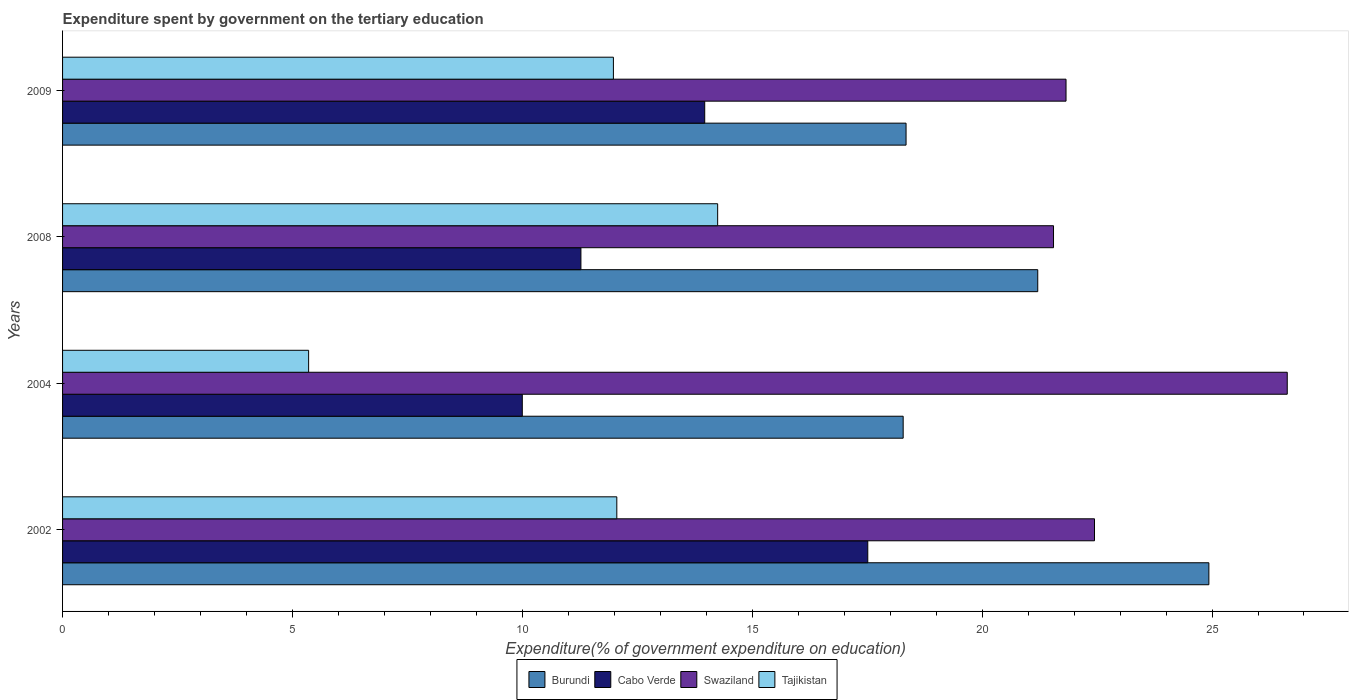How many groups of bars are there?
Give a very brief answer. 4. Are the number of bars per tick equal to the number of legend labels?
Provide a short and direct response. Yes. Are the number of bars on each tick of the Y-axis equal?
Ensure brevity in your answer.  Yes. How many bars are there on the 1st tick from the bottom?
Ensure brevity in your answer.  4. What is the expenditure spent by government on the tertiary education in Tajikistan in 2008?
Your response must be concise. 14.25. Across all years, what is the maximum expenditure spent by government on the tertiary education in Swaziland?
Keep it short and to the point. 26.64. Across all years, what is the minimum expenditure spent by government on the tertiary education in Burundi?
Make the answer very short. 18.28. In which year was the expenditure spent by government on the tertiary education in Tajikistan maximum?
Offer a terse response. 2008. In which year was the expenditure spent by government on the tertiary education in Cabo Verde minimum?
Your answer should be very brief. 2004. What is the total expenditure spent by government on the tertiary education in Cabo Verde in the graph?
Make the answer very short. 52.75. What is the difference between the expenditure spent by government on the tertiary education in Cabo Verde in 2004 and that in 2009?
Provide a short and direct response. -3.97. What is the difference between the expenditure spent by government on the tertiary education in Tajikistan in 2004 and the expenditure spent by government on the tertiary education in Swaziland in 2009?
Offer a very short reply. -16.47. What is the average expenditure spent by government on the tertiary education in Cabo Verde per year?
Your answer should be compact. 13.19. In the year 2009, what is the difference between the expenditure spent by government on the tertiary education in Swaziland and expenditure spent by government on the tertiary education in Cabo Verde?
Provide a short and direct response. 7.86. What is the ratio of the expenditure spent by government on the tertiary education in Tajikistan in 2008 to that in 2009?
Offer a terse response. 1.19. Is the expenditure spent by government on the tertiary education in Cabo Verde in 2008 less than that in 2009?
Provide a succinct answer. Yes. What is the difference between the highest and the second highest expenditure spent by government on the tertiary education in Cabo Verde?
Your answer should be very brief. 3.55. What is the difference between the highest and the lowest expenditure spent by government on the tertiary education in Tajikistan?
Make the answer very short. 8.9. In how many years, is the expenditure spent by government on the tertiary education in Cabo Verde greater than the average expenditure spent by government on the tertiary education in Cabo Verde taken over all years?
Give a very brief answer. 2. Is it the case that in every year, the sum of the expenditure spent by government on the tertiary education in Tajikistan and expenditure spent by government on the tertiary education in Burundi is greater than the sum of expenditure spent by government on the tertiary education in Swaziland and expenditure spent by government on the tertiary education in Cabo Verde?
Offer a terse response. No. What does the 2nd bar from the top in 2002 represents?
Offer a terse response. Swaziland. What does the 3rd bar from the bottom in 2004 represents?
Keep it short and to the point. Swaziland. Are all the bars in the graph horizontal?
Ensure brevity in your answer.  Yes. What is the difference between two consecutive major ticks on the X-axis?
Provide a succinct answer. 5. How many legend labels are there?
Your answer should be very brief. 4. How are the legend labels stacked?
Give a very brief answer. Horizontal. What is the title of the graph?
Make the answer very short. Expenditure spent by government on the tertiary education. Does "Egypt, Arab Rep." appear as one of the legend labels in the graph?
Give a very brief answer. No. What is the label or title of the X-axis?
Keep it short and to the point. Expenditure(% of government expenditure on education). What is the Expenditure(% of government expenditure on education) of Burundi in 2002?
Provide a short and direct response. 24.93. What is the Expenditure(% of government expenditure on education) of Cabo Verde in 2002?
Give a very brief answer. 17.51. What is the Expenditure(% of government expenditure on education) in Swaziland in 2002?
Your response must be concise. 22.44. What is the Expenditure(% of government expenditure on education) in Tajikistan in 2002?
Your response must be concise. 12.05. What is the Expenditure(% of government expenditure on education) in Burundi in 2004?
Your answer should be very brief. 18.28. What is the Expenditure(% of government expenditure on education) in Cabo Verde in 2004?
Keep it short and to the point. 10. What is the Expenditure(% of government expenditure on education) of Swaziland in 2004?
Keep it short and to the point. 26.64. What is the Expenditure(% of government expenditure on education) in Tajikistan in 2004?
Provide a succinct answer. 5.35. What is the Expenditure(% of government expenditure on education) of Burundi in 2008?
Your response must be concise. 21.21. What is the Expenditure(% of government expenditure on education) of Cabo Verde in 2008?
Your answer should be compact. 11.27. What is the Expenditure(% of government expenditure on education) in Swaziland in 2008?
Offer a terse response. 21.55. What is the Expenditure(% of government expenditure on education) in Tajikistan in 2008?
Offer a very short reply. 14.25. What is the Expenditure(% of government expenditure on education) of Burundi in 2009?
Provide a succinct answer. 18.35. What is the Expenditure(% of government expenditure on education) of Cabo Verde in 2009?
Give a very brief answer. 13.97. What is the Expenditure(% of government expenditure on education) in Swaziland in 2009?
Provide a short and direct response. 21.82. What is the Expenditure(% of government expenditure on education) in Tajikistan in 2009?
Offer a terse response. 11.98. Across all years, what is the maximum Expenditure(% of government expenditure on education) in Burundi?
Make the answer very short. 24.93. Across all years, what is the maximum Expenditure(% of government expenditure on education) of Cabo Verde?
Your answer should be very brief. 17.51. Across all years, what is the maximum Expenditure(% of government expenditure on education) of Swaziland?
Ensure brevity in your answer.  26.64. Across all years, what is the maximum Expenditure(% of government expenditure on education) of Tajikistan?
Provide a succinct answer. 14.25. Across all years, what is the minimum Expenditure(% of government expenditure on education) of Burundi?
Provide a short and direct response. 18.28. Across all years, what is the minimum Expenditure(% of government expenditure on education) of Cabo Verde?
Your response must be concise. 10. Across all years, what is the minimum Expenditure(% of government expenditure on education) in Swaziland?
Give a very brief answer. 21.55. Across all years, what is the minimum Expenditure(% of government expenditure on education) of Tajikistan?
Make the answer very short. 5.35. What is the total Expenditure(% of government expenditure on education) of Burundi in the graph?
Your answer should be compact. 82.77. What is the total Expenditure(% of government expenditure on education) in Cabo Verde in the graph?
Provide a short and direct response. 52.75. What is the total Expenditure(% of government expenditure on education) in Swaziland in the graph?
Keep it short and to the point. 92.46. What is the total Expenditure(% of government expenditure on education) of Tajikistan in the graph?
Offer a terse response. 43.63. What is the difference between the Expenditure(% of government expenditure on education) of Burundi in 2002 and that in 2004?
Offer a very short reply. 6.65. What is the difference between the Expenditure(% of government expenditure on education) in Cabo Verde in 2002 and that in 2004?
Give a very brief answer. 7.51. What is the difference between the Expenditure(% of government expenditure on education) of Swaziland in 2002 and that in 2004?
Ensure brevity in your answer.  -4.19. What is the difference between the Expenditure(% of government expenditure on education) of Tajikistan in 2002 and that in 2004?
Provide a succinct answer. 6.7. What is the difference between the Expenditure(% of government expenditure on education) of Burundi in 2002 and that in 2008?
Provide a succinct answer. 3.72. What is the difference between the Expenditure(% of government expenditure on education) of Cabo Verde in 2002 and that in 2008?
Your answer should be compact. 6.24. What is the difference between the Expenditure(% of government expenditure on education) of Swaziland in 2002 and that in 2008?
Ensure brevity in your answer.  0.89. What is the difference between the Expenditure(% of government expenditure on education) of Tajikistan in 2002 and that in 2008?
Your answer should be very brief. -2.19. What is the difference between the Expenditure(% of government expenditure on education) of Burundi in 2002 and that in 2009?
Your answer should be very brief. 6.59. What is the difference between the Expenditure(% of government expenditure on education) of Cabo Verde in 2002 and that in 2009?
Your answer should be very brief. 3.55. What is the difference between the Expenditure(% of government expenditure on education) in Swaziland in 2002 and that in 2009?
Your answer should be compact. 0.62. What is the difference between the Expenditure(% of government expenditure on education) in Tajikistan in 2002 and that in 2009?
Offer a very short reply. 0.07. What is the difference between the Expenditure(% of government expenditure on education) of Burundi in 2004 and that in 2008?
Provide a short and direct response. -2.93. What is the difference between the Expenditure(% of government expenditure on education) in Cabo Verde in 2004 and that in 2008?
Provide a short and direct response. -1.28. What is the difference between the Expenditure(% of government expenditure on education) of Swaziland in 2004 and that in 2008?
Give a very brief answer. 5.08. What is the difference between the Expenditure(% of government expenditure on education) in Tajikistan in 2004 and that in 2008?
Offer a very short reply. -8.9. What is the difference between the Expenditure(% of government expenditure on education) of Burundi in 2004 and that in 2009?
Offer a terse response. -0.06. What is the difference between the Expenditure(% of government expenditure on education) in Cabo Verde in 2004 and that in 2009?
Your answer should be compact. -3.97. What is the difference between the Expenditure(% of government expenditure on education) in Swaziland in 2004 and that in 2009?
Provide a succinct answer. 4.81. What is the difference between the Expenditure(% of government expenditure on education) in Tajikistan in 2004 and that in 2009?
Offer a very short reply. -6.63. What is the difference between the Expenditure(% of government expenditure on education) in Burundi in 2008 and that in 2009?
Make the answer very short. 2.86. What is the difference between the Expenditure(% of government expenditure on education) in Cabo Verde in 2008 and that in 2009?
Offer a terse response. -2.69. What is the difference between the Expenditure(% of government expenditure on education) of Swaziland in 2008 and that in 2009?
Provide a succinct answer. -0.27. What is the difference between the Expenditure(% of government expenditure on education) of Tajikistan in 2008 and that in 2009?
Your response must be concise. 2.27. What is the difference between the Expenditure(% of government expenditure on education) in Burundi in 2002 and the Expenditure(% of government expenditure on education) in Cabo Verde in 2004?
Ensure brevity in your answer.  14.93. What is the difference between the Expenditure(% of government expenditure on education) in Burundi in 2002 and the Expenditure(% of government expenditure on education) in Swaziland in 2004?
Your response must be concise. -1.7. What is the difference between the Expenditure(% of government expenditure on education) in Burundi in 2002 and the Expenditure(% of government expenditure on education) in Tajikistan in 2004?
Offer a terse response. 19.58. What is the difference between the Expenditure(% of government expenditure on education) of Cabo Verde in 2002 and the Expenditure(% of government expenditure on education) of Swaziland in 2004?
Your answer should be very brief. -9.12. What is the difference between the Expenditure(% of government expenditure on education) of Cabo Verde in 2002 and the Expenditure(% of government expenditure on education) of Tajikistan in 2004?
Provide a succinct answer. 12.16. What is the difference between the Expenditure(% of government expenditure on education) in Swaziland in 2002 and the Expenditure(% of government expenditure on education) in Tajikistan in 2004?
Ensure brevity in your answer.  17.09. What is the difference between the Expenditure(% of government expenditure on education) of Burundi in 2002 and the Expenditure(% of government expenditure on education) of Cabo Verde in 2008?
Provide a succinct answer. 13.66. What is the difference between the Expenditure(% of government expenditure on education) of Burundi in 2002 and the Expenditure(% of government expenditure on education) of Swaziland in 2008?
Provide a succinct answer. 3.38. What is the difference between the Expenditure(% of government expenditure on education) in Burundi in 2002 and the Expenditure(% of government expenditure on education) in Tajikistan in 2008?
Your answer should be compact. 10.68. What is the difference between the Expenditure(% of government expenditure on education) in Cabo Verde in 2002 and the Expenditure(% of government expenditure on education) in Swaziland in 2008?
Keep it short and to the point. -4.04. What is the difference between the Expenditure(% of government expenditure on education) in Cabo Verde in 2002 and the Expenditure(% of government expenditure on education) in Tajikistan in 2008?
Your response must be concise. 3.27. What is the difference between the Expenditure(% of government expenditure on education) of Swaziland in 2002 and the Expenditure(% of government expenditure on education) of Tajikistan in 2008?
Ensure brevity in your answer.  8.2. What is the difference between the Expenditure(% of government expenditure on education) in Burundi in 2002 and the Expenditure(% of government expenditure on education) in Cabo Verde in 2009?
Keep it short and to the point. 10.97. What is the difference between the Expenditure(% of government expenditure on education) of Burundi in 2002 and the Expenditure(% of government expenditure on education) of Swaziland in 2009?
Make the answer very short. 3.11. What is the difference between the Expenditure(% of government expenditure on education) in Burundi in 2002 and the Expenditure(% of government expenditure on education) in Tajikistan in 2009?
Offer a very short reply. 12.95. What is the difference between the Expenditure(% of government expenditure on education) in Cabo Verde in 2002 and the Expenditure(% of government expenditure on education) in Swaziland in 2009?
Offer a terse response. -4.31. What is the difference between the Expenditure(% of government expenditure on education) in Cabo Verde in 2002 and the Expenditure(% of government expenditure on education) in Tajikistan in 2009?
Ensure brevity in your answer.  5.53. What is the difference between the Expenditure(% of government expenditure on education) of Swaziland in 2002 and the Expenditure(% of government expenditure on education) of Tajikistan in 2009?
Provide a short and direct response. 10.46. What is the difference between the Expenditure(% of government expenditure on education) of Burundi in 2004 and the Expenditure(% of government expenditure on education) of Cabo Verde in 2008?
Make the answer very short. 7.01. What is the difference between the Expenditure(% of government expenditure on education) in Burundi in 2004 and the Expenditure(% of government expenditure on education) in Swaziland in 2008?
Your response must be concise. -3.27. What is the difference between the Expenditure(% of government expenditure on education) of Burundi in 2004 and the Expenditure(% of government expenditure on education) of Tajikistan in 2008?
Your answer should be very brief. 4.04. What is the difference between the Expenditure(% of government expenditure on education) of Cabo Verde in 2004 and the Expenditure(% of government expenditure on education) of Swaziland in 2008?
Make the answer very short. -11.55. What is the difference between the Expenditure(% of government expenditure on education) in Cabo Verde in 2004 and the Expenditure(% of government expenditure on education) in Tajikistan in 2008?
Your answer should be compact. -4.25. What is the difference between the Expenditure(% of government expenditure on education) in Swaziland in 2004 and the Expenditure(% of government expenditure on education) in Tajikistan in 2008?
Offer a very short reply. 12.39. What is the difference between the Expenditure(% of government expenditure on education) of Burundi in 2004 and the Expenditure(% of government expenditure on education) of Cabo Verde in 2009?
Your response must be concise. 4.32. What is the difference between the Expenditure(% of government expenditure on education) in Burundi in 2004 and the Expenditure(% of government expenditure on education) in Swaziland in 2009?
Your response must be concise. -3.54. What is the difference between the Expenditure(% of government expenditure on education) of Burundi in 2004 and the Expenditure(% of government expenditure on education) of Tajikistan in 2009?
Keep it short and to the point. 6.3. What is the difference between the Expenditure(% of government expenditure on education) of Cabo Verde in 2004 and the Expenditure(% of government expenditure on education) of Swaziland in 2009?
Provide a succinct answer. -11.83. What is the difference between the Expenditure(% of government expenditure on education) in Cabo Verde in 2004 and the Expenditure(% of government expenditure on education) in Tajikistan in 2009?
Give a very brief answer. -1.98. What is the difference between the Expenditure(% of government expenditure on education) in Swaziland in 2004 and the Expenditure(% of government expenditure on education) in Tajikistan in 2009?
Ensure brevity in your answer.  14.66. What is the difference between the Expenditure(% of government expenditure on education) of Burundi in 2008 and the Expenditure(% of government expenditure on education) of Cabo Verde in 2009?
Offer a very short reply. 7.24. What is the difference between the Expenditure(% of government expenditure on education) in Burundi in 2008 and the Expenditure(% of government expenditure on education) in Swaziland in 2009?
Offer a very short reply. -0.62. What is the difference between the Expenditure(% of government expenditure on education) in Burundi in 2008 and the Expenditure(% of government expenditure on education) in Tajikistan in 2009?
Your response must be concise. 9.23. What is the difference between the Expenditure(% of government expenditure on education) of Cabo Verde in 2008 and the Expenditure(% of government expenditure on education) of Swaziland in 2009?
Give a very brief answer. -10.55. What is the difference between the Expenditure(% of government expenditure on education) of Cabo Verde in 2008 and the Expenditure(% of government expenditure on education) of Tajikistan in 2009?
Offer a very short reply. -0.71. What is the difference between the Expenditure(% of government expenditure on education) in Swaziland in 2008 and the Expenditure(% of government expenditure on education) in Tajikistan in 2009?
Make the answer very short. 9.57. What is the average Expenditure(% of government expenditure on education) in Burundi per year?
Your answer should be very brief. 20.69. What is the average Expenditure(% of government expenditure on education) of Cabo Verde per year?
Give a very brief answer. 13.19. What is the average Expenditure(% of government expenditure on education) in Swaziland per year?
Make the answer very short. 23.11. What is the average Expenditure(% of government expenditure on education) in Tajikistan per year?
Your response must be concise. 10.91. In the year 2002, what is the difference between the Expenditure(% of government expenditure on education) in Burundi and Expenditure(% of government expenditure on education) in Cabo Verde?
Offer a terse response. 7.42. In the year 2002, what is the difference between the Expenditure(% of government expenditure on education) in Burundi and Expenditure(% of government expenditure on education) in Swaziland?
Offer a terse response. 2.49. In the year 2002, what is the difference between the Expenditure(% of government expenditure on education) of Burundi and Expenditure(% of government expenditure on education) of Tajikistan?
Give a very brief answer. 12.88. In the year 2002, what is the difference between the Expenditure(% of government expenditure on education) in Cabo Verde and Expenditure(% of government expenditure on education) in Swaziland?
Keep it short and to the point. -4.93. In the year 2002, what is the difference between the Expenditure(% of government expenditure on education) of Cabo Verde and Expenditure(% of government expenditure on education) of Tajikistan?
Ensure brevity in your answer.  5.46. In the year 2002, what is the difference between the Expenditure(% of government expenditure on education) of Swaziland and Expenditure(% of government expenditure on education) of Tajikistan?
Provide a succinct answer. 10.39. In the year 2004, what is the difference between the Expenditure(% of government expenditure on education) of Burundi and Expenditure(% of government expenditure on education) of Cabo Verde?
Your answer should be very brief. 8.28. In the year 2004, what is the difference between the Expenditure(% of government expenditure on education) of Burundi and Expenditure(% of government expenditure on education) of Swaziland?
Your response must be concise. -8.35. In the year 2004, what is the difference between the Expenditure(% of government expenditure on education) in Burundi and Expenditure(% of government expenditure on education) in Tajikistan?
Your response must be concise. 12.93. In the year 2004, what is the difference between the Expenditure(% of government expenditure on education) of Cabo Verde and Expenditure(% of government expenditure on education) of Swaziland?
Offer a very short reply. -16.64. In the year 2004, what is the difference between the Expenditure(% of government expenditure on education) of Cabo Verde and Expenditure(% of government expenditure on education) of Tajikistan?
Offer a terse response. 4.65. In the year 2004, what is the difference between the Expenditure(% of government expenditure on education) in Swaziland and Expenditure(% of government expenditure on education) in Tajikistan?
Your response must be concise. 21.28. In the year 2008, what is the difference between the Expenditure(% of government expenditure on education) in Burundi and Expenditure(% of government expenditure on education) in Cabo Verde?
Give a very brief answer. 9.94. In the year 2008, what is the difference between the Expenditure(% of government expenditure on education) of Burundi and Expenditure(% of government expenditure on education) of Swaziland?
Your answer should be very brief. -0.34. In the year 2008, what is the difference between the Expenditure(% of government expenditure on education) of Burundi and Expenditure(% of government expenditure on education) of Tajikistan?
Your answer should be compact. 6.96. In the year 2008, what is the difference between the Expenditure(% of government expenditure on education) of Cabo Verde and Expenditure(% of government expenditure on education) of Swaziland?
Offer a terse response. -10.28. In the year 2008, what is the difference between the Expenditure(% of government expenditure on education) of Cabo Verde and Expenditure(% of government expenditure on education) of Tajikistan?
Ensure brevity in your answer.  -2.97. In the year 2008, what is the difference between the Expenditure(% of government expenditure on education) of Swaziland and Expenditure(% of government expenditure on education) of Tajikistan?
Give a very brief answer. 7.3. In the year 2009, what is the difference between the Expenditure(% of government expenditure on education) of Burundi and Expenditure(% of government expenditure on education) of Cabo Verde?
Offer a very short reply. 4.38. In the year 2009, what is the difference between the Expenditure(% of government expenditure on education) in Burundi and Expenditure(% of government expenditure on education) in Swaziland?
Your answer should be compact. -3.48. In the year 2009, what is the difference between the Expenditure(% of government expenditure on education) in Burundi and Expenditure(% of government expenditure on education) in Tajikistan?
Offer a terse response. 6.36. In the year 2009, what is the difference between the Expenditure(% of government expenditure on education) of Cabo Verde and Expenditure(% of government expenditure on education) of Swaziland?
Offer a very short reply. -7.86. In the year 2009, what is the difference between the Expenditure(% of government expenditure on education) in Cabo Verde and Expenditure(% of government expenditure on education) in Tajikistan?
Provide a short and direct response. 1.99. In the year 2009, what is the difference between the Expenditure(% of government expenditure on education) of Swaziland and Expenditure(% of government expenditure on education) of Tajikistan?
Ensure brevity in your answer.  9.84. What is the ratio of the Expenditure(% of government expenditure on education) of Burundi in 2002 to that in 2004?
Keep it short and to the point. 1.36. What is the ratio of the Expenditure(% of government expenditure on education) of Cabo Verde in 2002 to that in 2004?
Your response must be concise. 1.75. What is the ratio of the Expenditure(% of government expenditure on education) of Swaziland in 2002 to that in 2004?
Your answer should be very brief. 0.84. What is the ratio of the Expenditure(% of government expenditure on education) of Tajikistan in 2002 to that in 2004?
Your response must be concise. 2.25. What is the ratio of the Expenditure(% of government expenditure on education) in Burundi in 2002 to that in 2008?
Give a very brief answer. 1.18. What is the ratio of the Expenditure(% of government expenditure on education) in Cabo Verde in 2002 to that in 2008?
Ensure brevity in your answer.  1.55. What is the ratio of the Expenditure(% of government expenditure on education) of Swaziland in 2002 to that in 2008?
Your answer should be compact. 1.04. What is the ratio of the Expenditure(% of government expenditure on education) of Tajikistan in 2002 to that in 2008?
Provide a short and direct response. 0.85. What is the ratio of the Expenditure(% of government expenditure on education) in Burundi in 2002 to that in 2009?
Offer a very short reply. 1.36. What is the ratio of the Expenditure(% of government expenditure on education) in Cabo Verde in 2002 to that in 2009?
Your answer should be very brief. 1.25. What is the ratio of the Expenditure(% of government expenditure on education) of Swaziland in 2002 to that in 2009?
Ensure brevity in your answer.  1.03. What is the ratio of the Expenditure(% of government expenditure on education) of Burundi in 2004 to that in 2008?
Offer a terse response. 0.86. What is the ratio of the Expenditure(% of government expenditure on education) in Cabo Verde in 2004 to that in 2008?
Offer a terse response. 0.89. What is the ratio of the Expenditure(% of government expenditure on education) in Swaziland in 2004 to that in 2008?
Offer a very short reply. 1.24. What is the ratio of the Expenditure(% of government expenditure on education) in Tajikistan in 2004 to that in 2008?
Your answer should be very brief. 0.38. What is the ratio of the Expenditure(% of government expenditure on education) of Cabo Verde in 2004 to that in 2009?
Offer a very short reply. 0.72. What is the ratio of the Expenditure(% of government expenditure on education) in Swaziland in 2004 to that in 2009?
Keep it short and to the point. 1.22. What is the ratio of the Expenditure(% of government expenditure on education) of Tajikistan in 2004 to that in 2009?
Your answer should be compact. 0.45. What is the ratio of the Expenditure(% of government expenditure on education) of Burundi in 2008 to that in 2009?
Your answer should be compact. 1.16. What is the ratio of the Expenditure(% of government expenditure on education) of Cabo Verde in 2008 to that in 2009?
Offer a terse response. 0.81. What is the ratio of the Expenditure(% of government expenditure on education) in Swaziland in 2008 to that in 2009?
Your answer should be compact. 0.99. What is the ratio of the Expenditure(% of government expenditure on education) in Tajikistan in 2008 to that in 2009?
Ensure brevity in your answer.  1.19. What is the difference between the highest and the second highest Expenditure(% of government expenditure on education) of Burundi?
Make the answer very short. 3.72. What is the difference between the highest and the second highest Expenditure(% of government expenditure on education) in Cabo Verde?
Ensure brevity in your answer.  3.55. What is the difference between the highest and the second highest Expenditure(% of government expenditure on education) in Swaziland?
Make the answer very short. 4.19. What is the difference between the highest and the second highest Expenditure(% of government expenditure on education) of Tajikistan?
Ensure brevity in your answer.  2.19. What is the difference between the highest and the lowest Expenditure(% of government expenditure on education) in Burundi?
Provide a short and direct response. 6.65. What is the difference between the highest and the lowest Expenditure(% of government expenditure on education) in Cabo Verde?
Your answer should be very brief. 7.51. What is the difference between the highest and the lowest Expenditure(% of government expenditure on education) of Swaziland?
Provide a short and direct response. 5.08. What is the difference between the highest and the lowest Expenditure(% of government expenditure on education) of Tajikistan?
Your answer should be very brief. 8.9. 